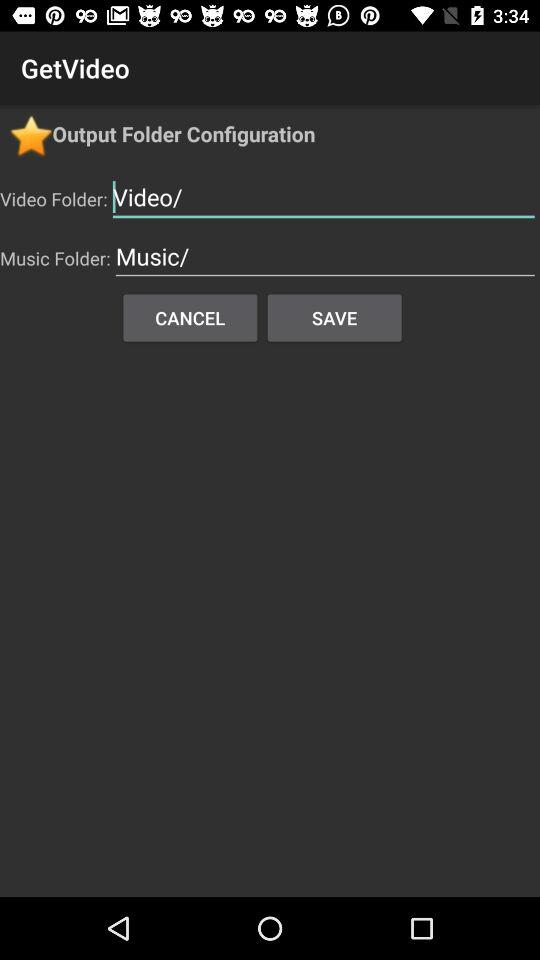What might be the function of the 'Save' and 'Cancel' buttons shown in the configuration settings? In the 'GetVideo' app's configuration dialog, the 'Save' button is used to apply and save any changes made to the folder paths for videos and music. The 'Cancel' button allows users to disregard changes and exit the configuration dialog without altering the current settings. 